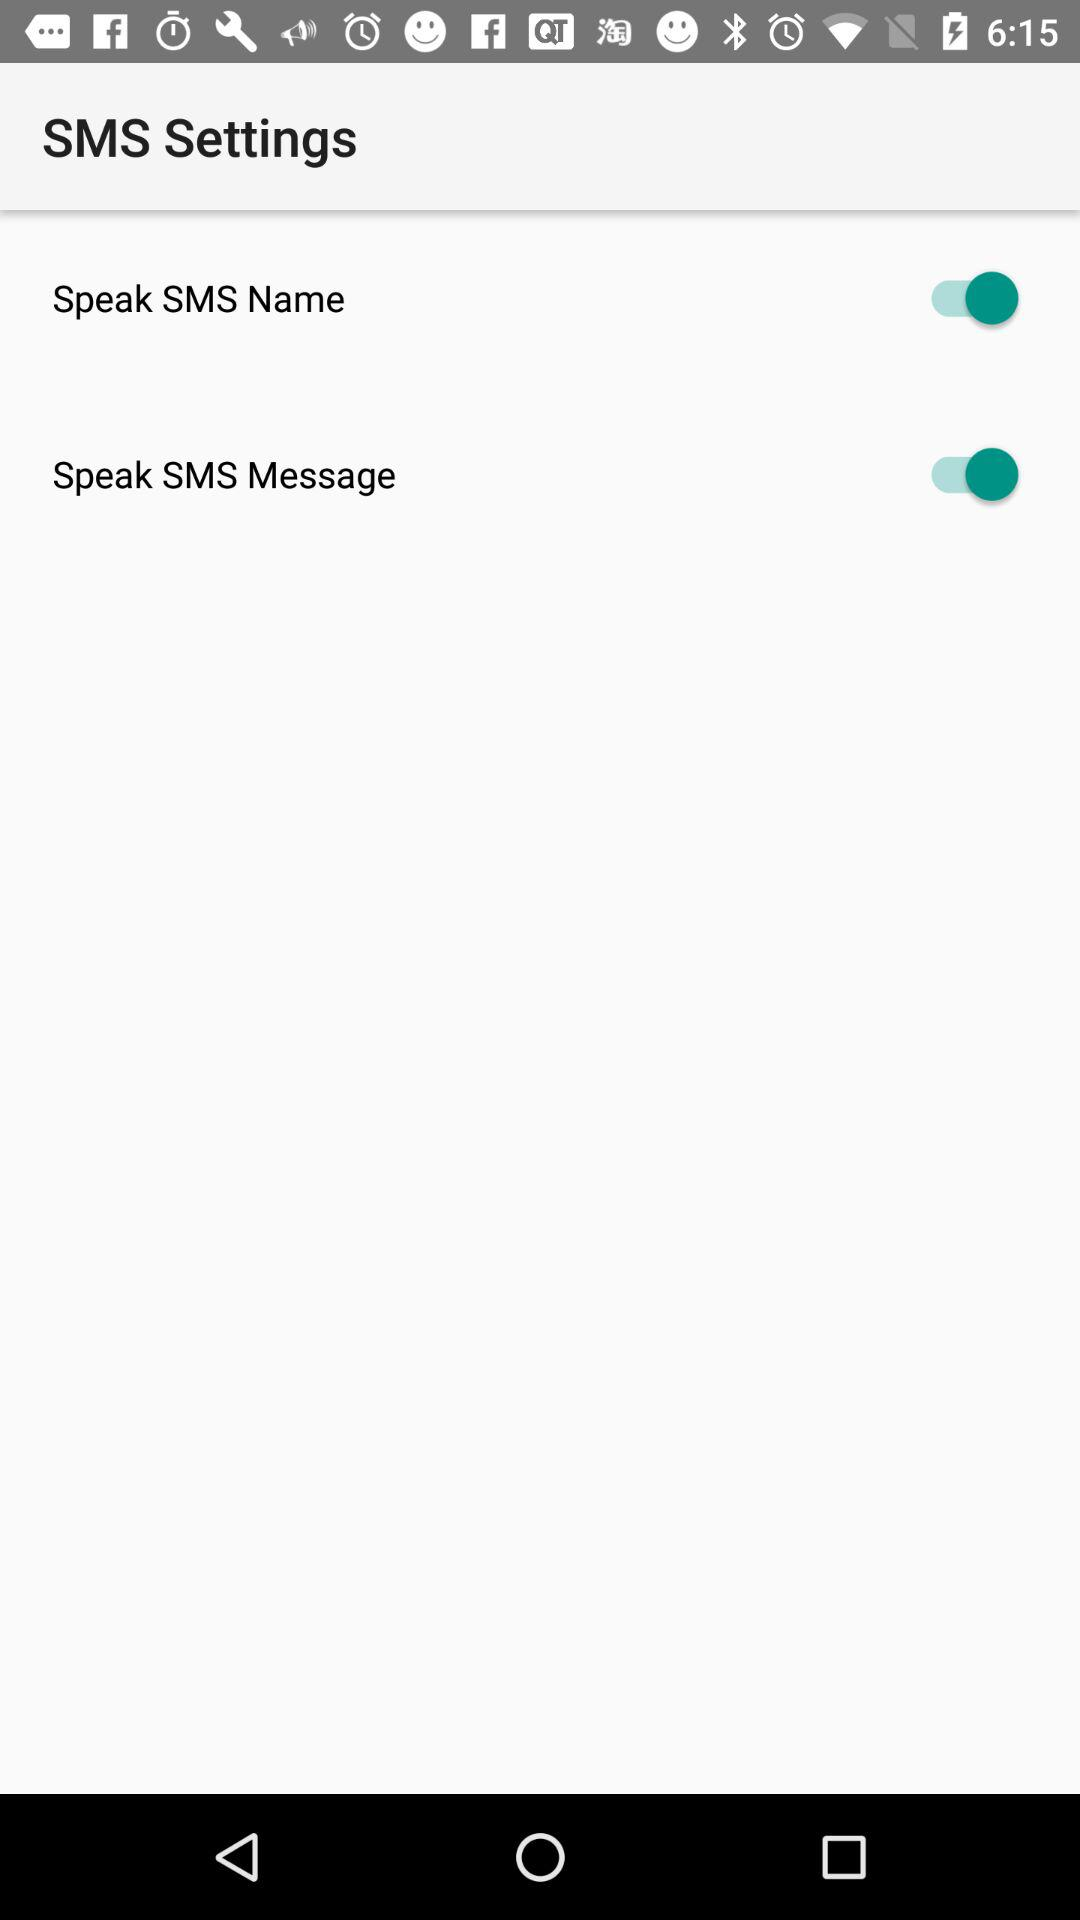What is the status of the Speak SMS Name? The status is on. 